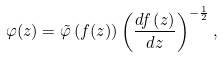<formula> <loc_0><loc_0><loc_500><loc_500>\varphi ( z ) = \tilde { \varphi } \left ( f ( z ) \right ) \left ( \frac { d f \left ( z \right ) } { d z } \right ) ^ { - \frac { 1 } { 2 } } ,</formula> 